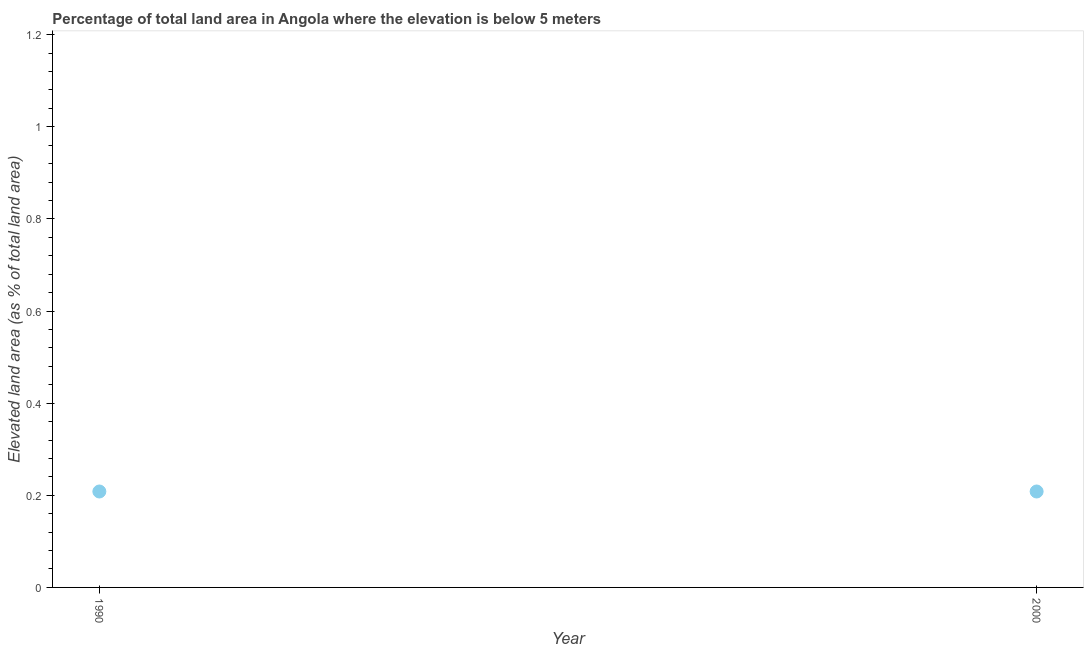What is the total elevated land area in 2000?
Offer a very short reply. 0.21. Across all years, what is the maximum total elevated land area?
Keep it short and to the point. 0.21. Across all years, what is the minimum total elevated land area?
Offer a terse response. 0.21. What is the sum of the total elevated land area?
Offer a terse response. 0.42. What is the difference between the total elevated land area in 1990 and 2000?
Your answer should be compact. 0. What is the average total elevated land area per year?
Your answer should be very brief. 0.21. What is the median total elevated land area?
Give a very brief answer. 0.21. In how many years, is the total elevated land area greater than 1.12 %?
Keep it short and to the point. 0. Do a majority of the years between 2000 and 1990 (inclusive) have total elevated land area greater than 1 %?
Provide a succinct answer. No. Is the total elevated land area in 1990 less than that in 2000?
Offer a very short reply. No. How many years are there in the graph?
Offer a terse response. 2. What is the difference between two consecutive major ticks on the Y-axis?
Ensure brevity in your answer.  0.2. What is the title of the graph?
Your answer should be compact. Percentage of total land area in Angola where the elevation is below 5 meters. What is the label or title of the X-axis?
Keep it short and to the point. Year. What is the label or title of the Y-axis?
Keep it short and to the point. Elevated land area (as % of total land area). What is the Elevated land area (as % of total land area) in 1990?
Your response must be concise. 0.21. What is the Elevated land area (as % of total land area) in 2000?
Provide a short and direct response. 0.21. What is the difference between the Elevated land area (as % of total land area) in 1990 and 2000?
Provide a short and direct response. 0. 